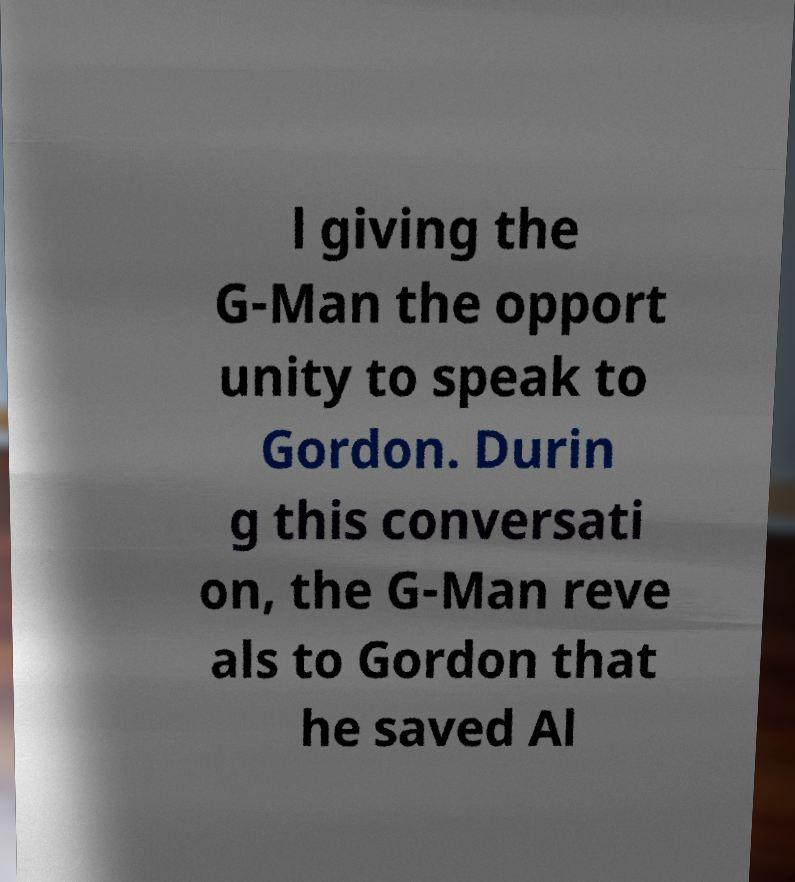There's text embedded in this image that I need extracted. Can you transcribe it verbatim? l giving the G-Man the opport unity to speak to Gordon. Durin g this conversati on, the G-Man reve als to Gordon that he saved Al 